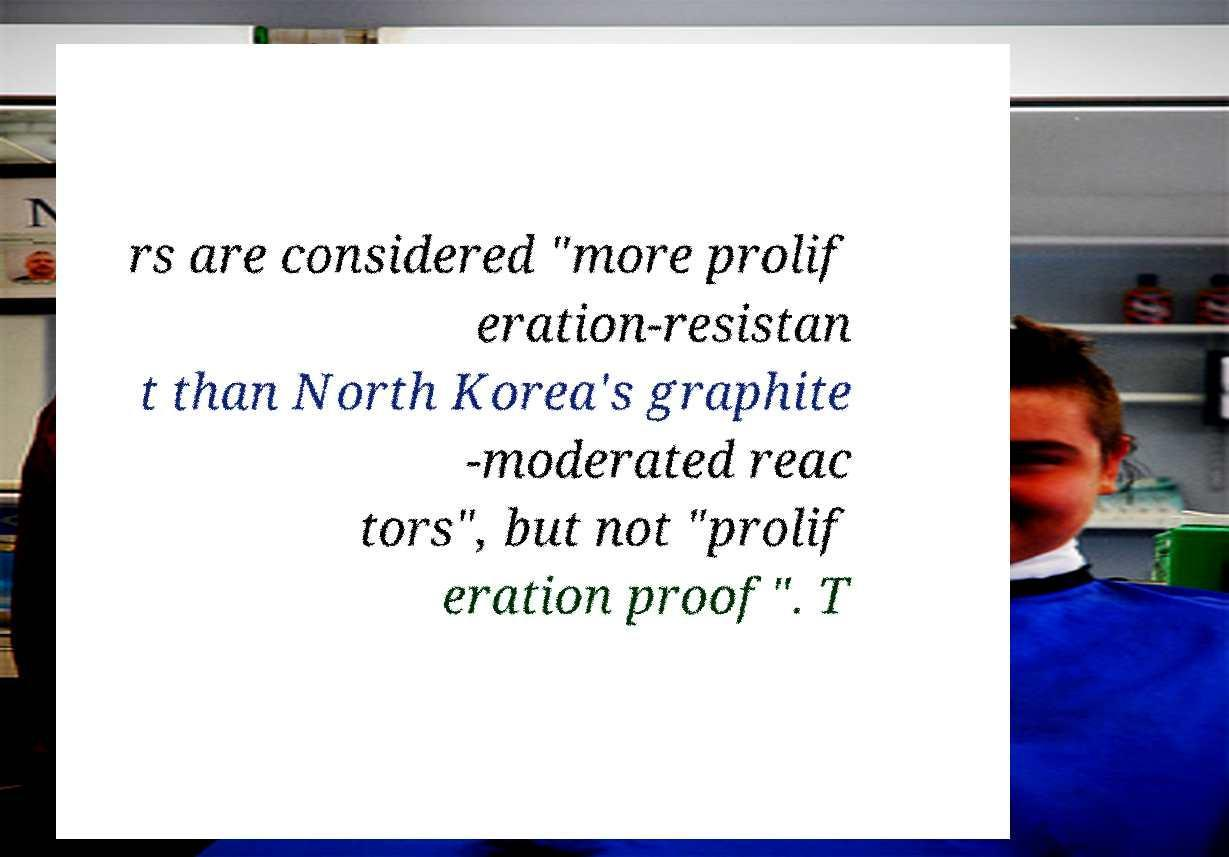What messages or text are displayed in this image? I need them in a readable, typed format. rs are considered "more prolif eration-resistan t than North Korea's graphite -moderated reac tors", but not "prolif eration proof". T 